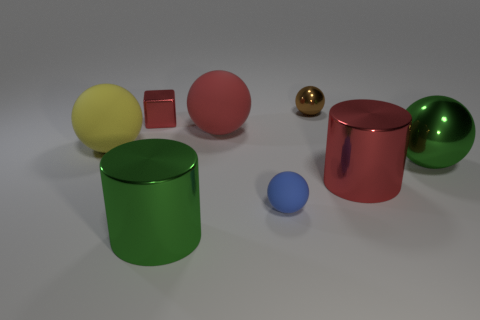Subtract 2 spheres. How many spheres are left? 3 Add 1 blue balls. How many objects exist? 9 Subtract all cylinders. How many objects are left? 6 Add 5 big metallic things. How many big metallic things are left? 8 Add 2 small gray shiny cubes. How many small gray shiny cubes exist? 2 Subtract 0 purple blocks. How many objects are left? 8 Subtract all big cyan metallic spheres. Subtract all red blocks. How many objects are left? 7 